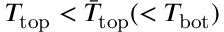Convert formula to latex. <formula><loc_0><loc_0><loc_500><loc_500>T _ { t o p } < \bar { T } _ { t o p } ( < T _ { b o t } )</formula> 